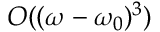Convert formula to latex. <formula><loc_0><loc_0><loc_500><loc_500>O ( ( \omega - \omega _ { 0 } ) ^ { 3 } )</formula> 